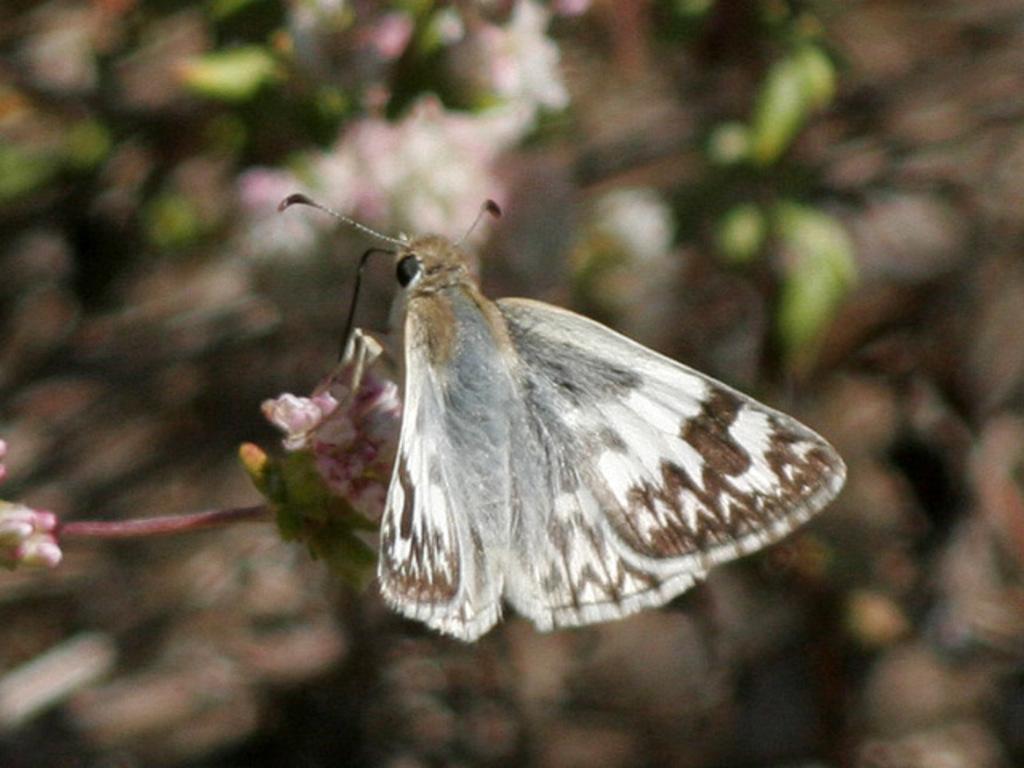Can you describe this image briefly? In this image we can see a butterfly on a flower. 